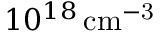<formula> <loc_0><loc_0><loc_500><loc_500>1 0 ^ { 1 8 } \, c m ^ { - 3 }</formula> 